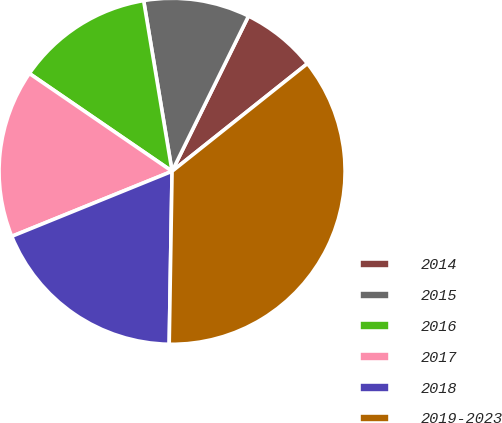Convert chart. <chart><loc_0><loc_0><loc_500><loc_500><pie_chart><fcel>2014<fcel>2015<fcel>2016<fcel>2017<fcel>2018<fcel>2019-2023<nl><fcel>7.02%<fcel>9.91%<fcel>12.81%<fcel>15.7%<fcel>18.6%<fcel>35.96%<nl></chart> 